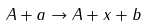<formula> <loc_0><loc_0><loc_500><loc_500>A + a \rightarrow A + x + b</formula> 